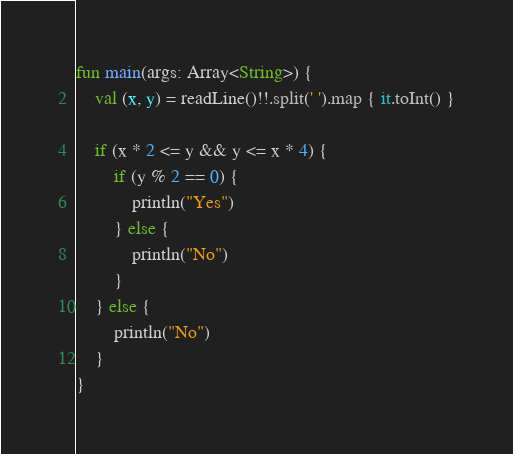Convert code to text. <code><loc_0><loc_0><loc_500><loc_500><_Kotlin_>fun main(args: Array<String>) {
    val (x, y) = readLine()!!.split(' ').map { it.toInt() }

    if (x * 2 <= y && y <= x * 4) {
        if (y % 2 == 0) {
            println("Yes")
        } else {
            println("No")
        }
    } else {
        println("No")
    }
}</code> 